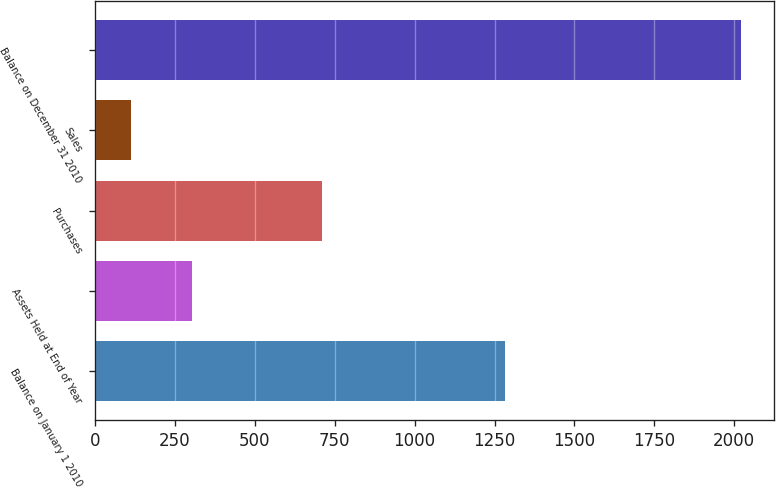<chart> <loc_0><loc_0><loc_500><loc_500><bar_chart><fcel>Balance on January 1 2010<fcel>Assets Held at End of Year<fcel>Purchases<fcel>Sales<fcel>Balance on December 31 2010<nl><fcel>1284<fcel>302.2<fcel>711<fcel>111<fcel>2023<nl></chart> 